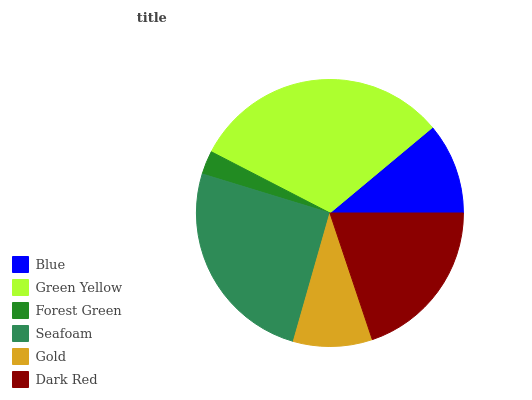Is Forest Green the minimum?
Answer yes or no. Yes. Is Green Yellow the maximum?
Answer yes or no. Yes. Is Green Yellow the minimum?
Answer yes or no. No. Is Forest Green the maximum?
Answer yes or no. No. Is Green Yellow greater than Forest Green?
Answer yes or no. Yes. Is Forest Green less than Green Yellow?
Answer yes or no. Yes. Is Forest Green greater than Green Yellow?
Answer yes or no. No. Is Green Yellow less than Forest Green?
Answer yes or no. No. Is Dark Red the high median?
Answer yes or no. Yes. Is Blue the low median?
Answer yes or no. Yes. Is Gold the high median?
Answer yes or no. No. Is Seafoam the low median?
Answer yes or no. No. 